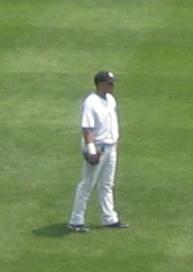How many of this man's feet are flat on the ground?
Concise answer only. 2. Was this picture taken at night?
Be succinct. No. Is the man drunk?
Write a very short answer. No. Is the picture in focus?
Give a very brief answer. No. 